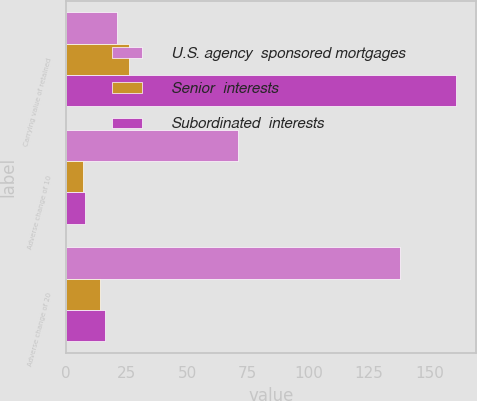Convert chart to OTSL. <chart><loc_0><loc_0><loc_500><loc_500><stacked_bar_chart><ecel><fcel>Carrying value of retained<fcel>Adverse change of 10<fcel>Adverse change of 20<nl><fcel>U.S. agency  sponsored mortgages<fcel>21<fcel>71<fcel>138<nl><fcel>Senior  interests<fcel>26<fcel>7<fcel>14<nl><fcel>Subordinated  interests<fcel>161<fcel>8<fcel>16<nl></chart> 